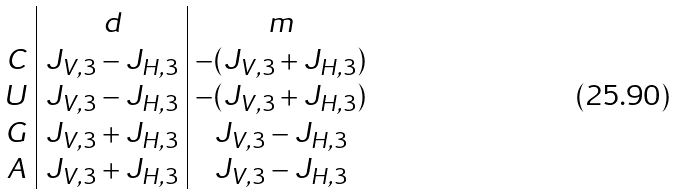Convert formula to latex. <formula><loc_0><loc_0><loc_500><loc_500>\begin{array} { c | c | c } & d & m \\ C & J _ { V , 3 } - J _ { H , 3 } & - ( J _ { V , 3 } + J _ { H , 3 } ) \\ U & J _ { V , 3 } - J _ { H , 3 } & - ( J _ { V , 3 } + J _ { H , 3 } ) \\ G & J _ { V , 3 } + J _ { H , 3 } & J _ { V , 3 } - J _ { H , 3 } \\ A & J _ { V , 3 } + J _ { H , 3 } & J _ { V , 3 } - J _ { H , 3 } \\ \end{array}</formula> 